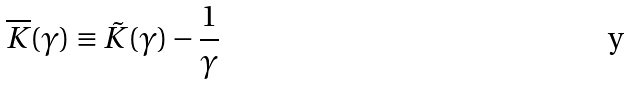Convert formula to latex. <formula><loc_0><loc_0><loc_500><loc_500>\overline { K } ( \gamma ) \equiv \tilde { K } ( \gamma ) - \frac { 1 } { \gamma }</formula> 